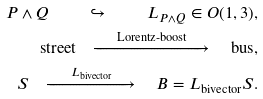Convert formula to latex. <formula><loc_0><loc_0><loc_500><loc_500>P \wedge Q \quad \hookrightarrow \quad L _ { P \wedge Q } \in O ( 1 , 3 ) , \\ \text {street} \quad \xrightarrow { \quad \text {Lorentz-boost} \quad } \quad \text {bus} , \\ S \quad \xrightarrow { \quad L _ { \text {bivector} } \quad } \quad B = L _ { \text {bivector} } S .</formula> 